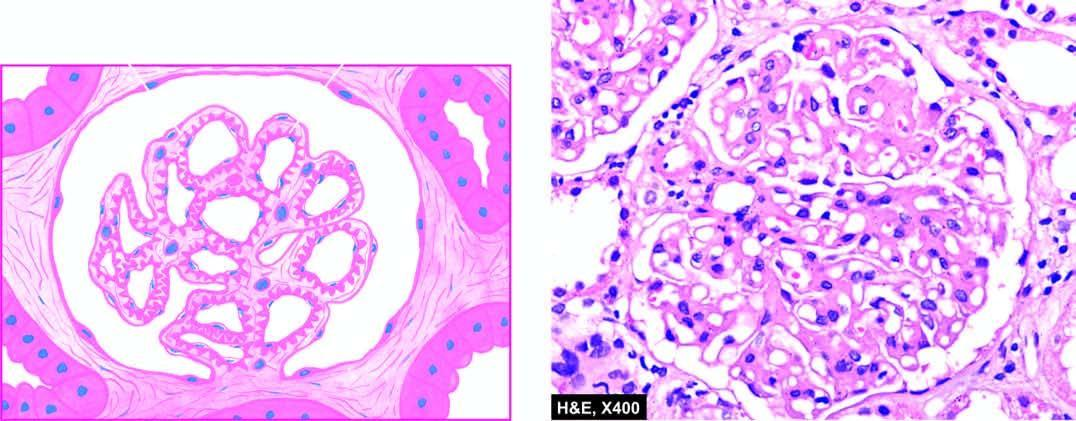what are diffusely thickened due to duplication of the gbm?
Answer the question using a single word or phrase. Capillary walls 